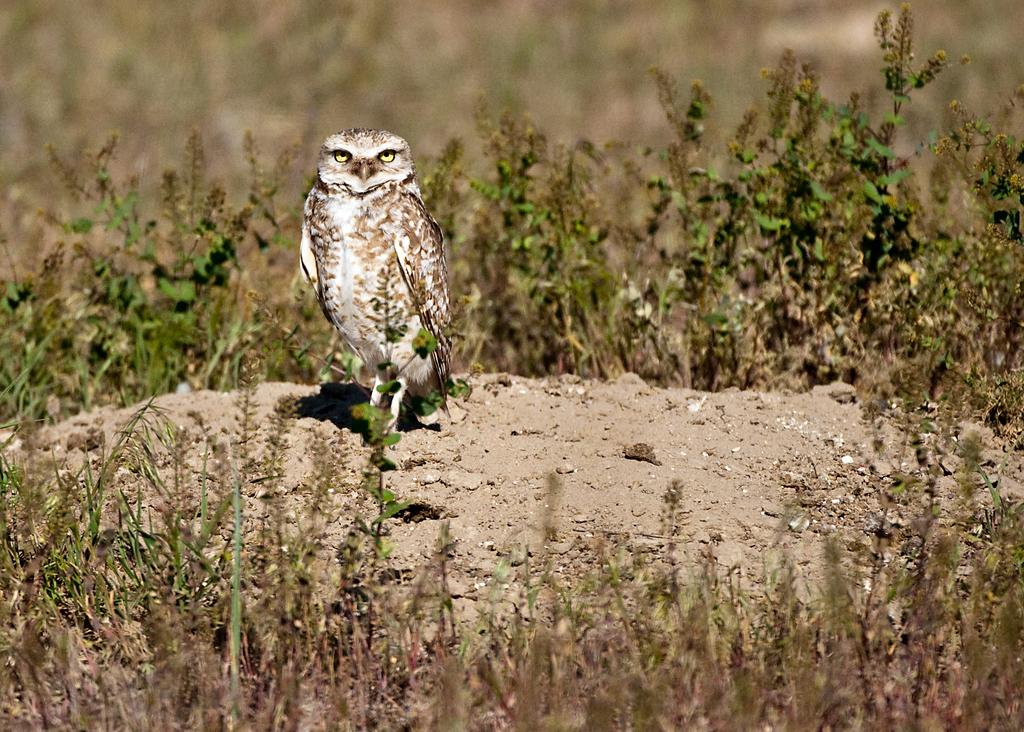What animal is present in the image? There is an owl in the image. What is the owl's position in the image? The owl is standing on the ground. What can be seen in the background of the image? There are plants in the background of the image. How would you describe the image's quality at the top? The image is blurred at the top. What is present at the bottom of the image? There are plants at the bottom of the image. What historical event is depicted in the image? There is no historical event depicted in the image; it features an owl standing on the ground. What weather condition can be observed in the image? The image does not show any weather conditions; it is focused on the owl and the surrounding plants. 